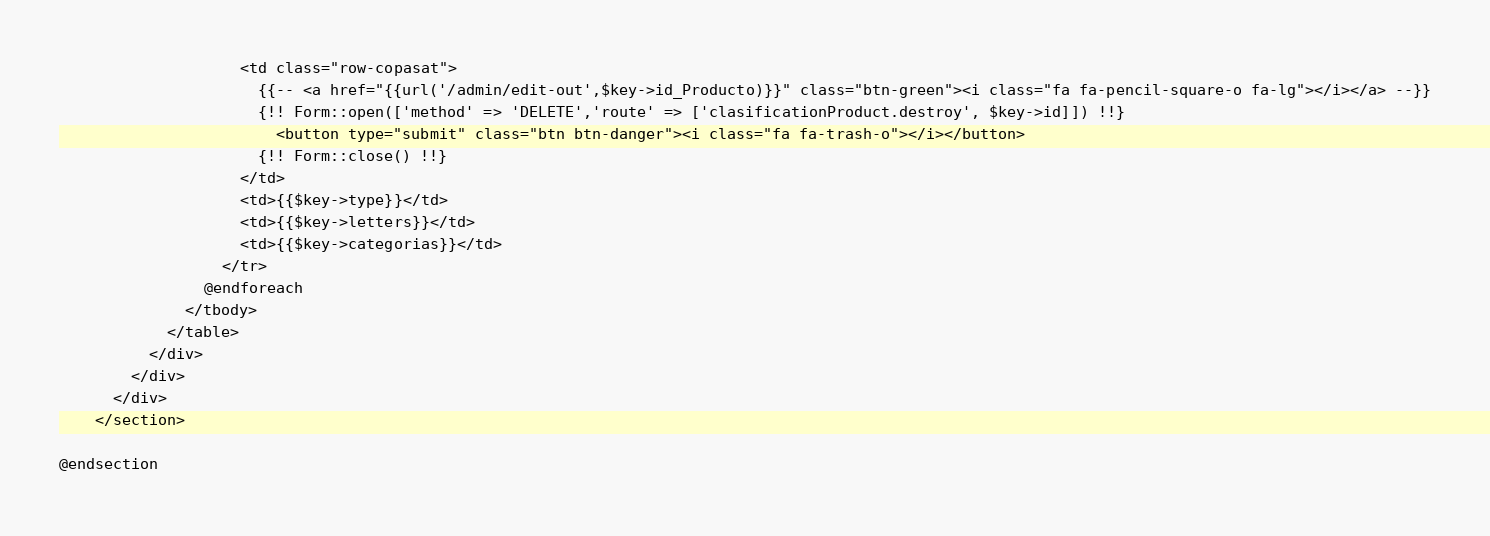Convert code to text. <code><loc_0><loc_0><loc_500><loc_500><_PHP_>                    <td class="row-copasat">
                      {{-- <a href="{{url('/admin/edit-out',$key->id_Producto)}}" class="btn-green"><i class="fa fa-pencil-square-o fa-lg"></i></a> --}}
                      {!! Form::open(['method' => 'DELETE','route' => ['clasificationProduct.destroy', $key->id]]) !!}
                        <button type="submit" class="btn btn-danger"><i class="fa fa-trash-o"></i></button>
                      {!! Form::close() !!}
                    </td>
                    <td>{{$key->type}}</td>
                    <td>{{$key->letters}}</td>
                    <td>{{$key->categorias}}</td>
                  </tr>
                @endforeach
              </tbody>
            </table>
          </div>
        </div>
      </div>
    </section>

@endsection
</code> 